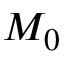Convert formula to latex. <formula><loc_0><loc_0><loc_500><loc_500>M _ { 0 }</formula> 